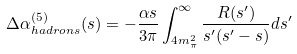Convert formula to latex. <formula><loc_0><loc_0><loc_500><loc_500>\Delta \alpha _ { h a d r o n s } ^ { ( 5 ) } ( s ) = - \frac { \alpha s } { 3 \pi } \int _ { 4 m _ { \pi } ^ { 2 } } ^ { \infty } \frac { R ( s ^ { \prime } ) } { s ^ { \prime } ( s ^ { \prime } - s ) } d s ^ { \prime }</formula> 